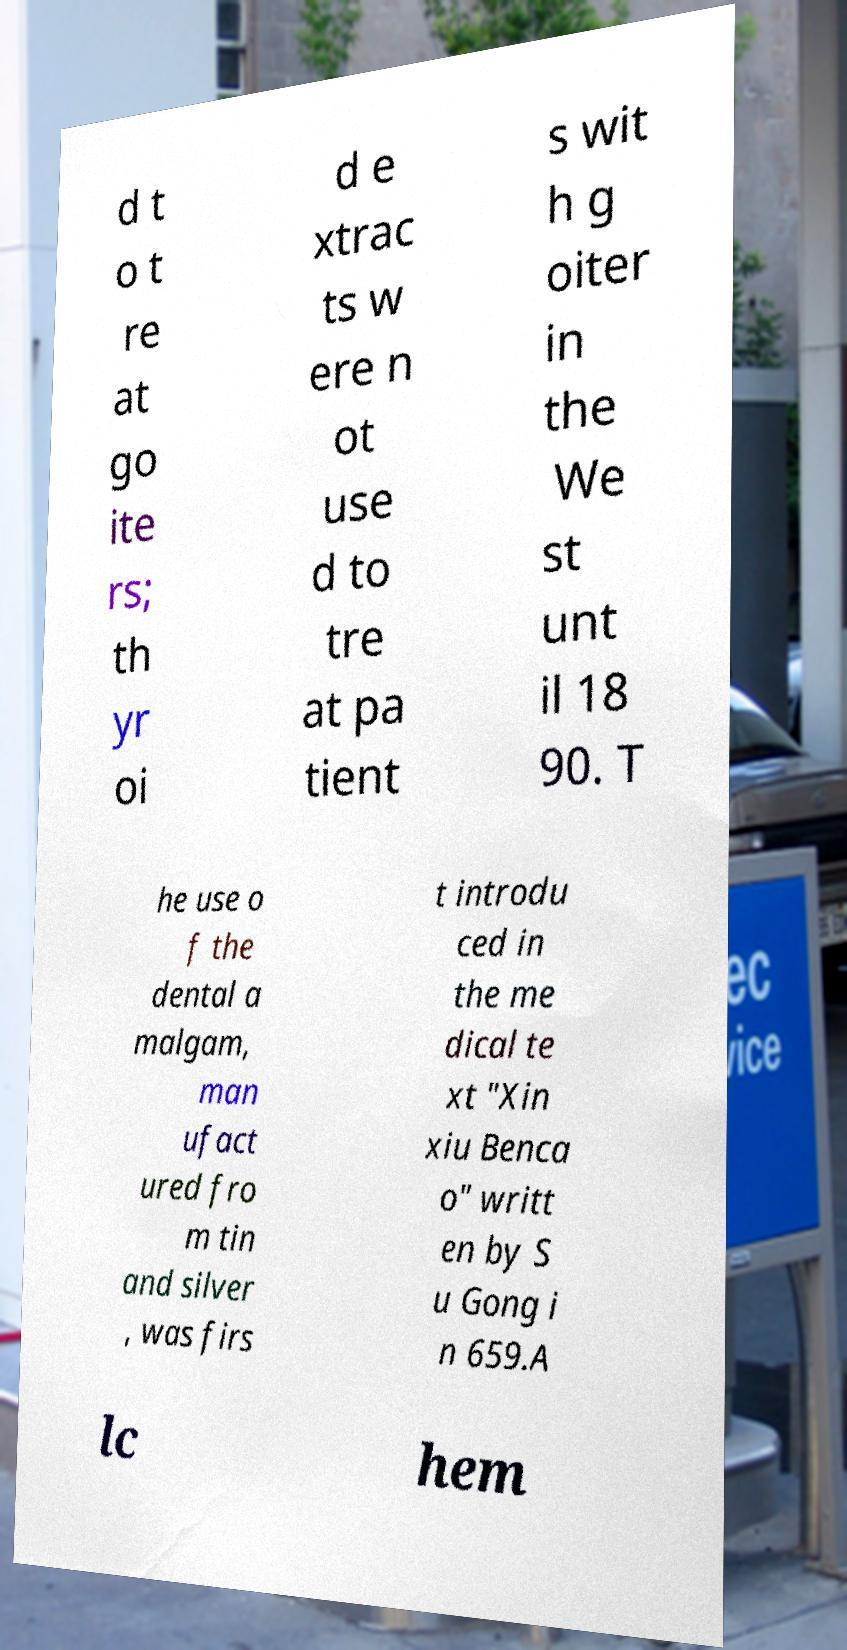There's text embedded in this image that I need extracted. Can you transcribe it verbatim? d t o t re at go ite rs; th yr oi d e xtrac ts w ere n ot use d to tre at pa tient s wit h g oiter in the We st unt il 18 90. T he use o f the dental a malgam, man ufact ured fro m tin and silver , was firs t introdu ced in the me dical te xt "Xin xiu Benca o" writt en by S u Gong i n 659.A lc hem 